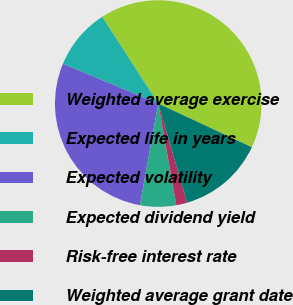Convert chart to OTSL. <chart><loc_0><loc_0><loc_500><loc_500><pie_chart><fcel>Weighted average exercise<fcel>Expected life in years<fcel>Expected volatility<fcel>Expected dividend yield<fcel>Risk-free interest rate<fcel>Weighted average grant date<nl><fcel>41.09%<fcel>9.59%<fcel>28.44%<fcel>5.65%<fcel>1.71%<fcel>13.53%<nl></chart> 